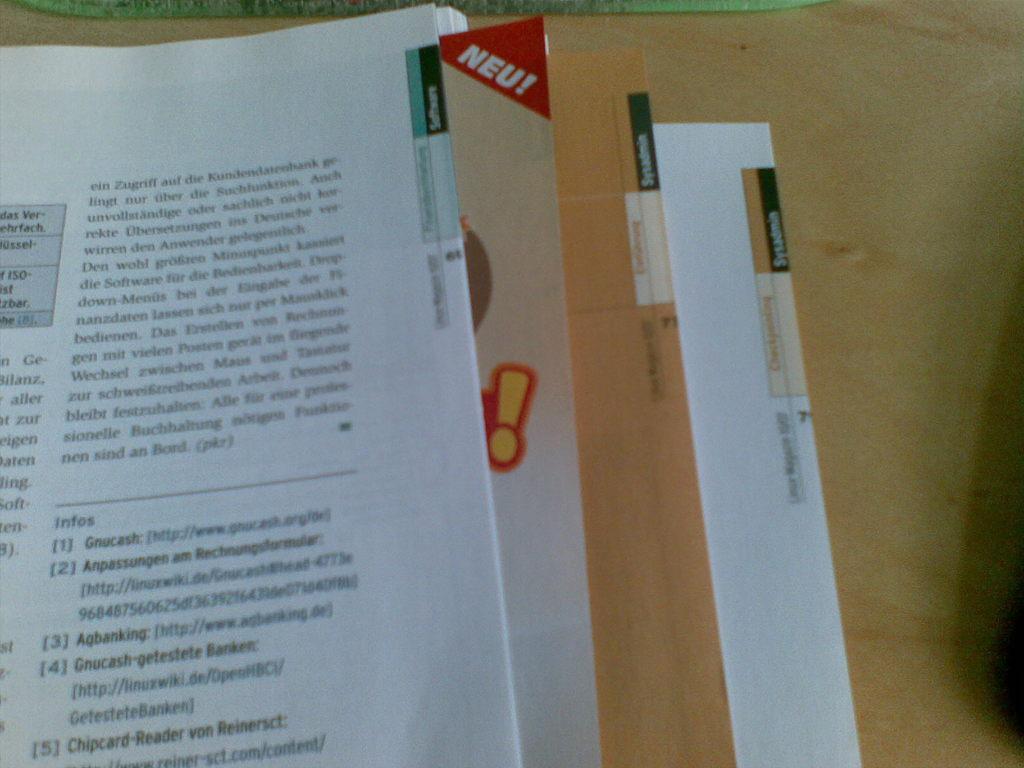Does the page have a link on it?
Offer a terse response. Yes. 